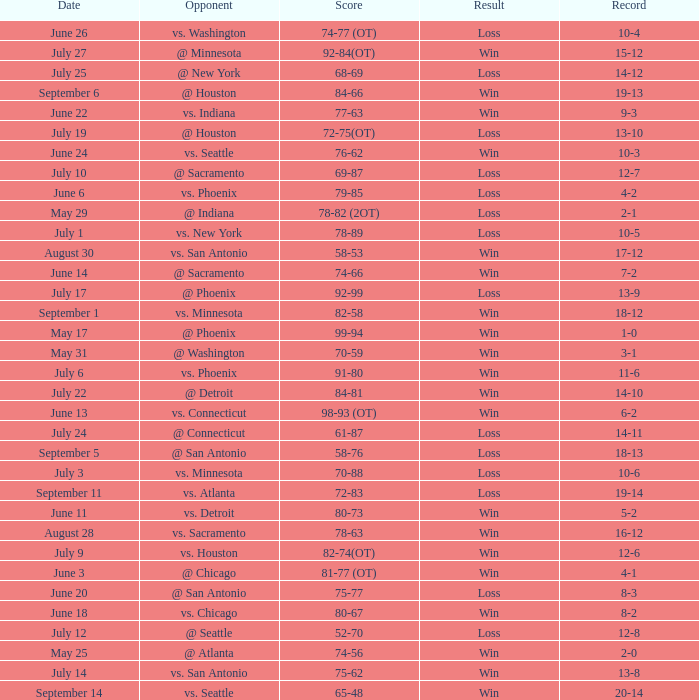What is the Opponent of the game with a Score of 74-66? @ Sacramento. 